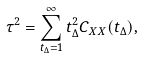<formula> <loc_0><loc_0><loc_500><loc_500>\tau ^ { 2 } = \sum _ { t _ { \Delta } = 1 } ^ { \infty } t _ { \Delta } ^ { 2 } C _ { X X } ( t _ { \Delta } ) ,</formula> 